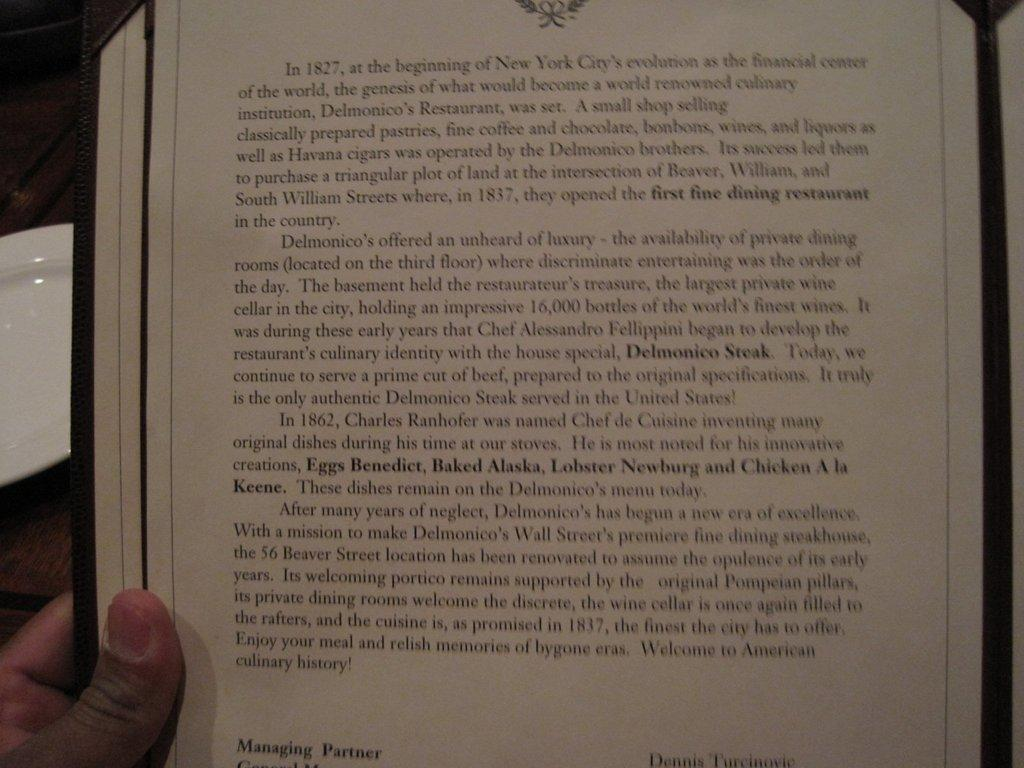<image>
Write a terse but informative summary of the picture. A page long account tells the story of the beginning of Delmonico's Restaurant. 